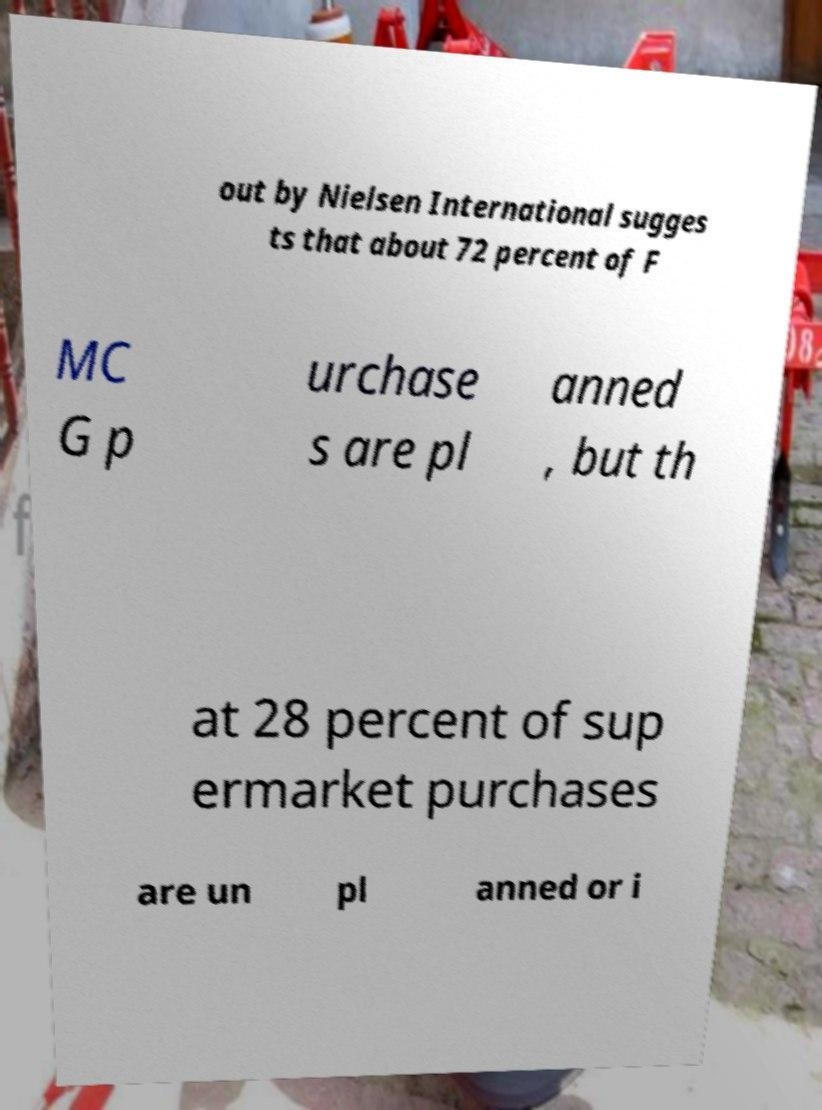I need the written content from this picture converted into text. Can you do that? out by Nielsen International sugges ts that about 72 percent of F MC G p urchase s are pl anned , but th at 28 percent of sup ermarket purchases are un pl anned or i 